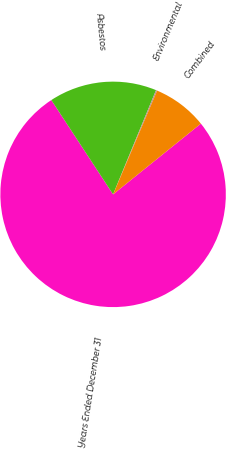Convert chart. <chart><loc_0><loc_0><loc_500><loc_500><pie_chart><fcel>Years Ended December 31<fcel>Asbestos<fcel>Environmental<fcel>Combined<nl><fcel>76.56%<fcel>15.45%<fcel>0.17%<fcel>7.81%<nl></chart> 